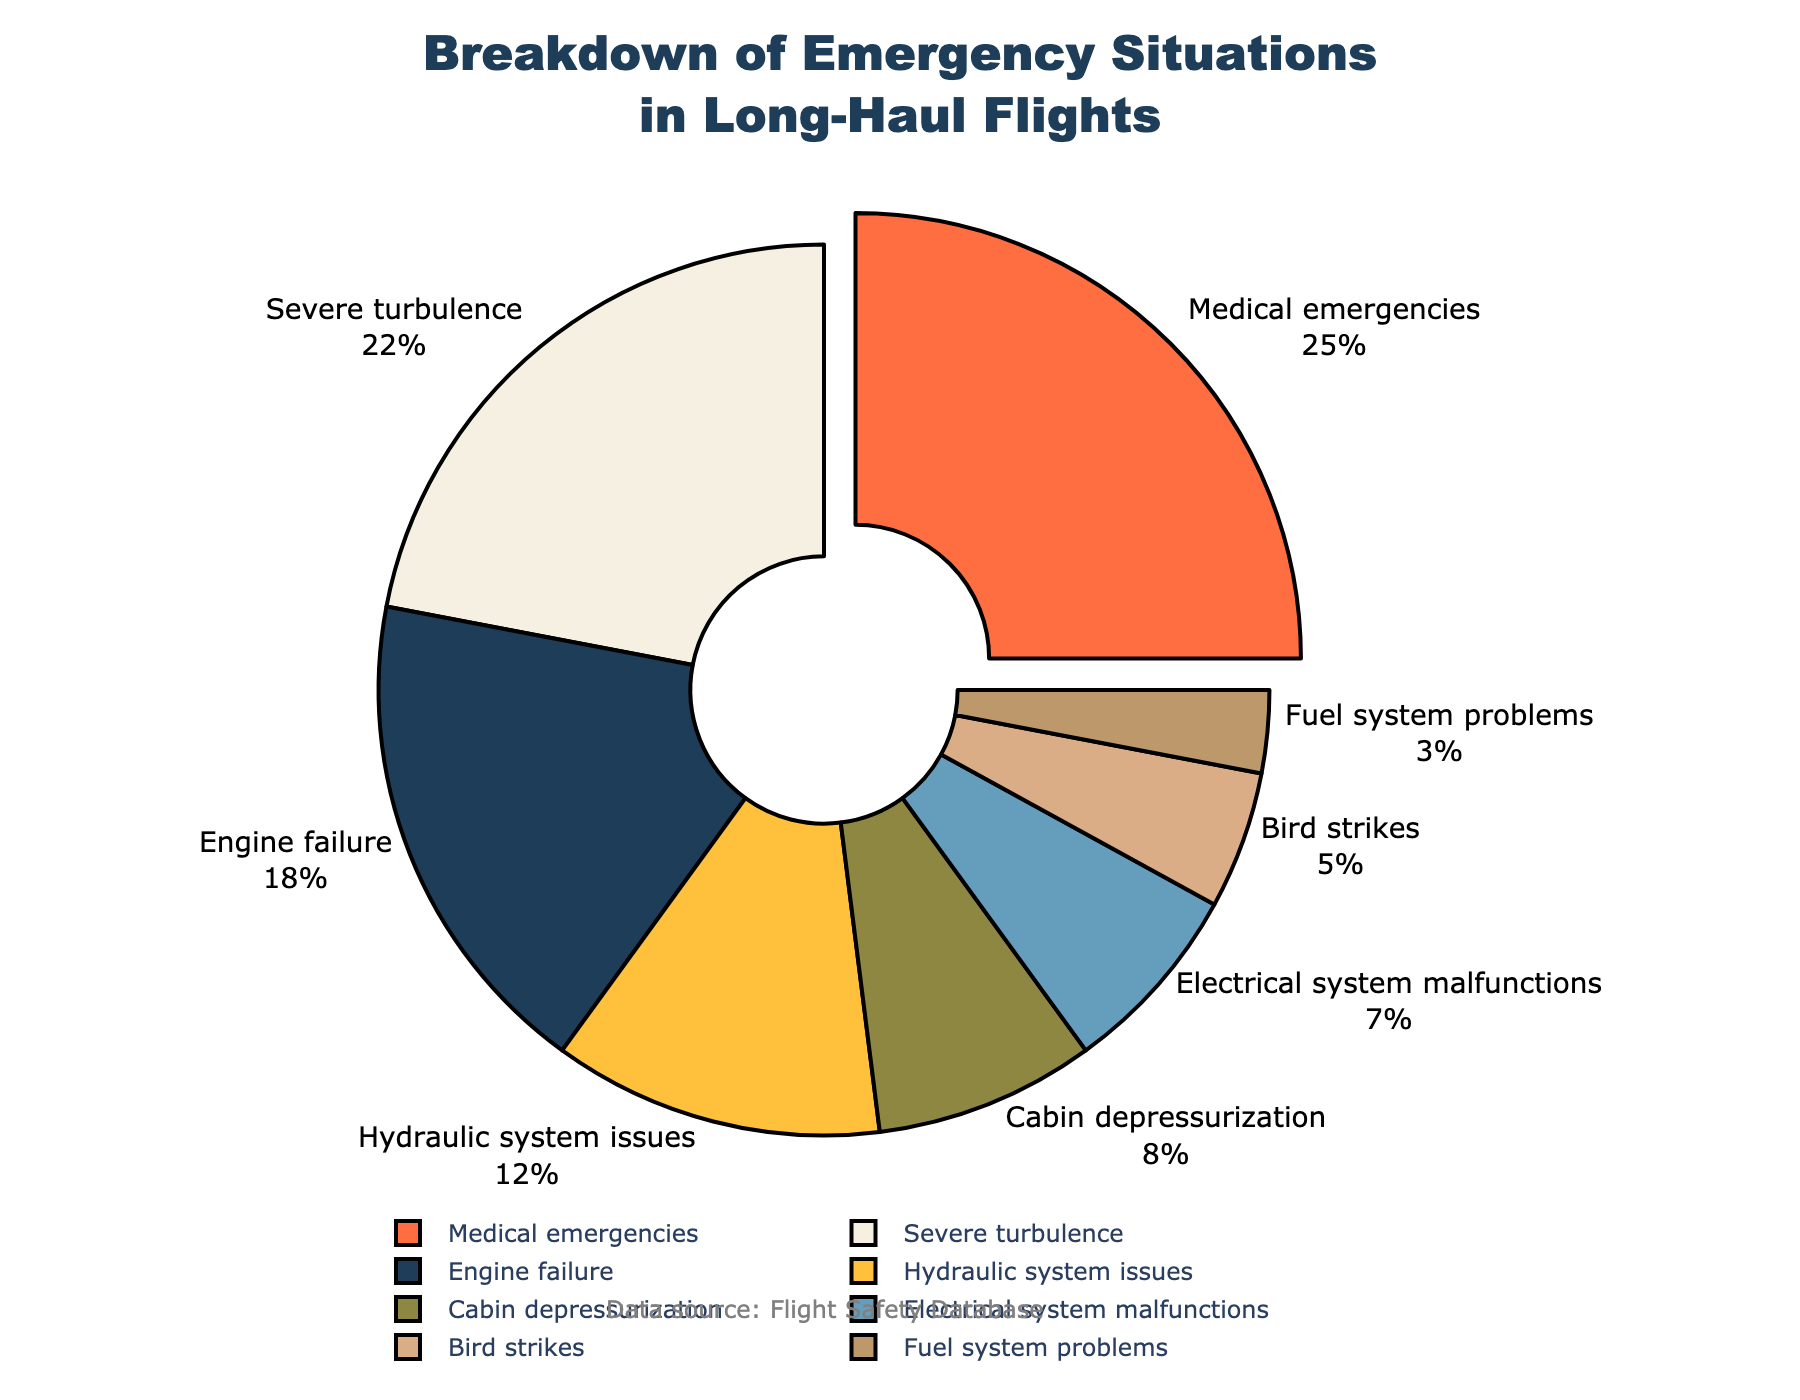What's the most common emergency situation encountered during long-haul flights? The pie chart shows the percentage breakdown of various emergency situations. By looking at the segments, the largest segment corresponds to the highest percentage. From the chart, Medical emergencies have the largest segment at 25%.
Answer: Medical emergencies Which emergency situation is the second most frequent? After identifying the most frequent emergency (Medical emergencies at 25%), the next largest segment represents the second most frequent. Severe turbulence is the second largest with 22%.
Answer: Severe turbulence How much more common are medical emergencies compared to electrical system malfunctions? To compare Medical emergencies (25%) and Electrical system malfunctions (7%), we calculate the difference. 25% - 7% = 18%. Medical emergencies are 18% more common than Electrical system malfunctions.
Answer: 18% What emergency situations together comprise half (50%) of the emergencies? By adding up the percentages in descending order until reaching approximately 50%, Medical emergencies (25%) + Severe turbulence (22%) = 47%. While not exactly 50%, these two categories together make up the majority nearing half.
Answer: Medical emergencies and Severe turbulence Which emergency is represented by the smallest slice of the pie chart? The smallest slice corresponds to the smallest percentage. From the chart, Fuel system problems have the smallest percentage at 3%.
Answer: Fuel system problems Compare the combined percentage of Engine failures and Bird strikes to Severe turbulence. Which is higher, and by how much? Engine failures (18%) and Bird strikes (5%) combined give 18% + 5% = 23%. Severe turbulence alone is 22%. The combined value is higher by 23% - 22% = 1%.
Answer: Combined percentage is higher by 1% Are Electrical system malfunctions more frequent than Bird strikes? Referring to the pie chart, Electrical system malfunctions account for 7%, while Bird strikes account for 5%. Since 7% is greater than 5%, Electrical system malfunctions are more frequent.
Answer: Yes What visual feature distinguishes the most common emergency situation from the others? The most common emergency (Medical emergencies) segment is slightly pulled outwards from the rest, making it visually distinct.
Answer: It is pulled outwards If you sum the proportions of hydraulic system issues and cabin depressurization, what percentage of the total do they represent? Hydraulic system issues account for 12% and Cabin depressurization accounts for 8%. Summing these gives 12% + 8% = 20%.
Answer: 20% What is the percentage difference between cabin depressurization and bird strikes? Cabin depressurization is 8% and Bird strikes are 5%. The difference is calculated as 8% - 5% = 3%.
Answer: 3% 